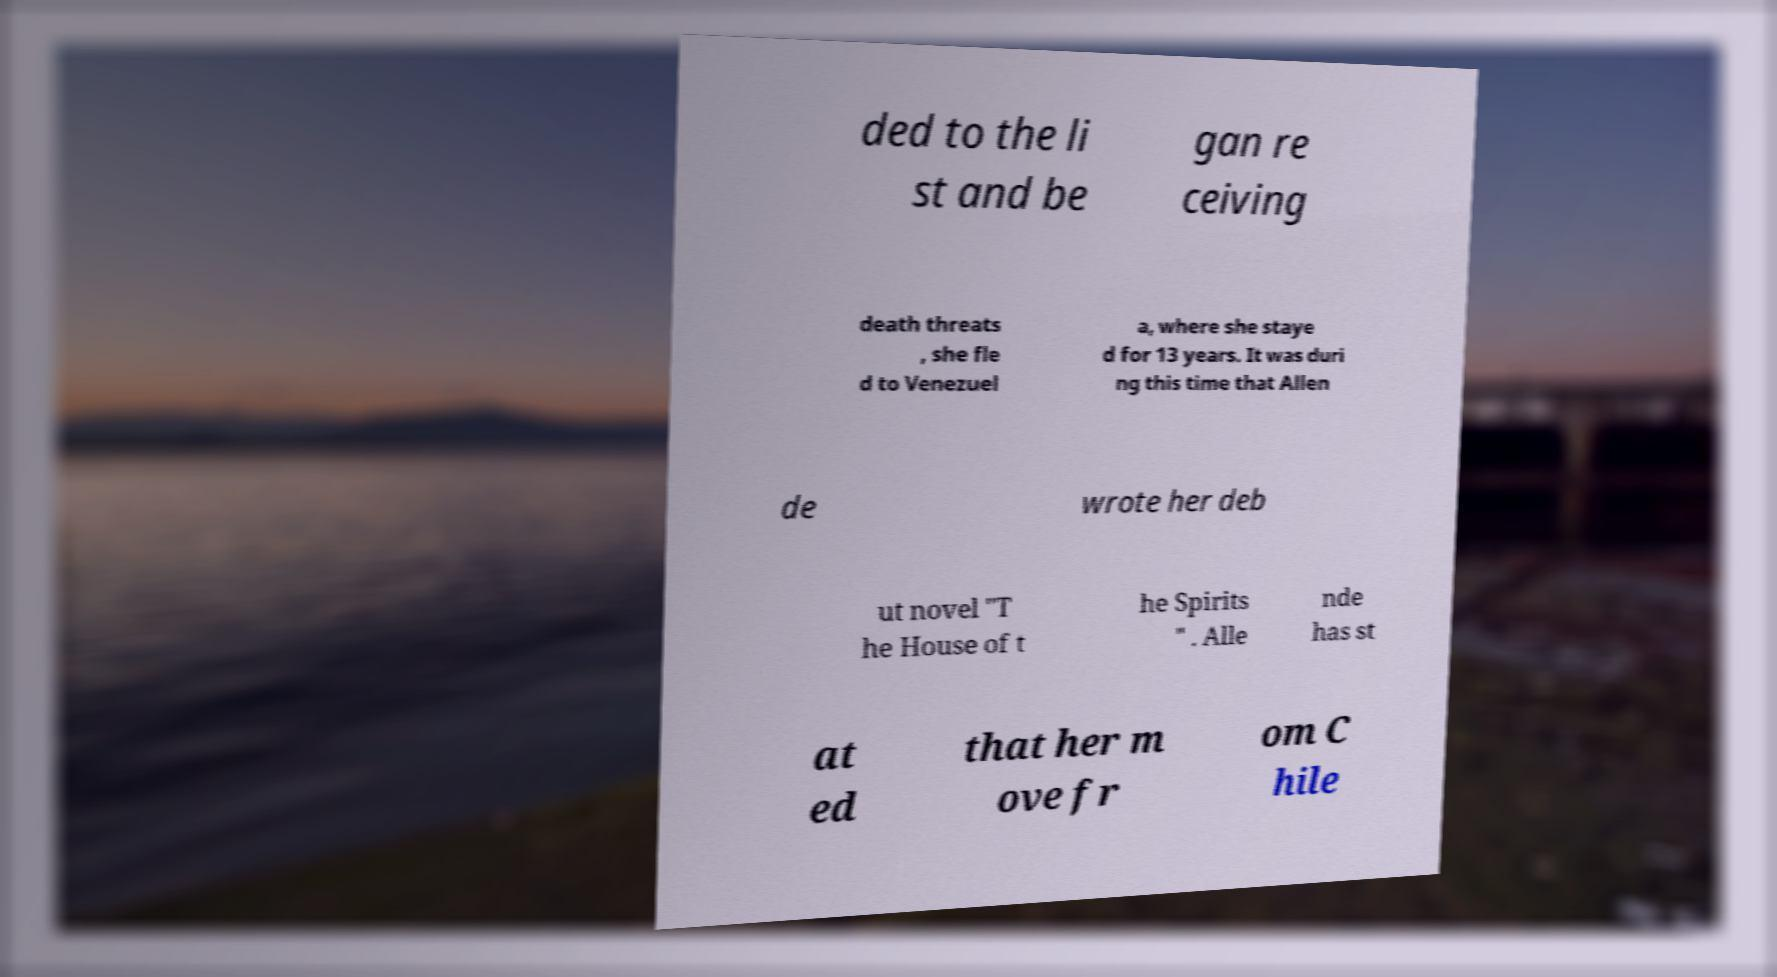Could you assist in decoding the text presented in this image and type it out clearly? ded to the li st and be gan re ceiving death threats , she fle d to Venezuel a, where she staye d for 13 years. It was duri ng this time that Allen de wrote her deb ut novel "T he House of t he Spirits " . Alle nde has st at ed that her m ove fr om C hile 